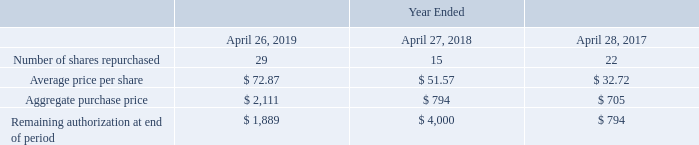Stock Repurchase Program
As of April 26, 2019, our Board of Directors has authorized the repurchase of up to $13.6 billion of our common stock under our stock repurchase program . Under this program, which we may suspend or discontinue at any time, we may purchase shares of our outstanding common stock through solicited or unsolicited transactions in the open market, in privately negotiated transactions, through accelerated share repurchase programs, pursuant to a Rule 10b5-1 plan or in such other manner as deemed appropriate by our management.
The following table summarizes activity related to this program (in millions, except per share amounts):
The aggregate purchase price of our stock repurchases for fiscal 2019 consisted of $2.1 billion of open market purchases of which $1.0 billion and $1.1 billion were allocated to additional paid-in capital and retained earnings (accumulated deficit), respectively.
Since the May 13, 2003 inception of our stock repurchase program through April 26, 2019, we repurchased a total of 313 million shares of our common stock at an average price of $37.46 per share, for an aggregate purchase price of $11.7 billion.
Which years does the table provide information for number of shares repurchased under the company's stock repurchase program? 2019, 2018, 2017. What did the company's Board of Directors authorize as of 2019? The repurchase of up to $13.6 billion of our common stock under our stock repurchase program. What was the Aggregate purchase price in 2018?
Answer scale should be: million. 794. What was the change in the Aggregate purchase price between 2018 and 2019?
Answer scale should be: million. 2,111-794
Answer: 1317. What was the change in the average price per share between 2017 and 2018? 51.57-32.72
Answer: 18.85. What was the percentage change in the Remaining authorization at end of period between 2018 and 2019?
Answer scale should be: percent. (1,889-4,000)/4,000
Answer: -52.78. 